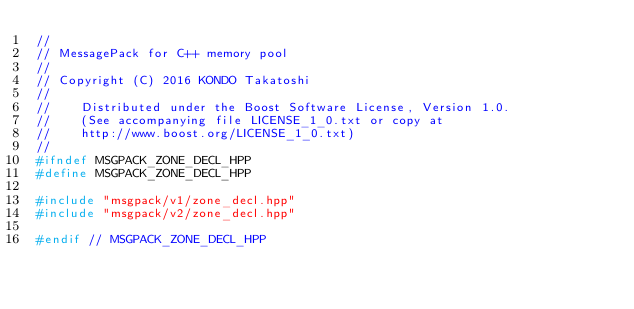Convert code to text. <code><loc_0><loc_0><loc_500><loc_500><_C++_>//
// MessagePack for C++ memory pool
//
// Copyright (C) 2016 KONDO Takatoshi
//
//    Distributed under the Boost Software License, Version 1.0.
//    (See accompanying file LICENSE_1_0.txt or copy at
//    http://www.boost.org/LICENSE_1_0.txt)
//
#ifndef MSGPACK_ZONE_DECL_HPP
#define MSGPACK_ZONE_DECL_HPP

#include "msgpack/v1/zone_decl.hpp"
#include "msgpack/v2/zone_decl.hpp"

#endif // MSGPACK_ZONE_DECL_HPP
</code> 